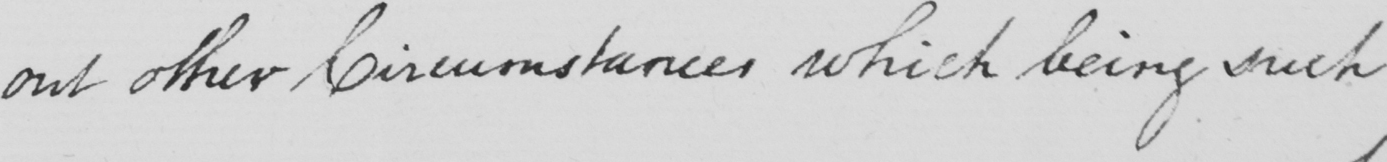Please transcribe the handwritten text in this image. out other Circumstances which being such 